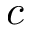Convert formula to latex. <formula><loc_0><loc_0><loc_500><loc_500>c</formula> 